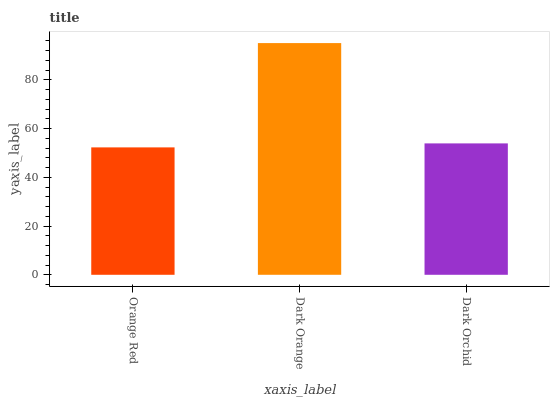Is Orange Red the minimum?
Answer yes or no. Yes. Is Dark Orange the maximum?
Answer yes or no. Yes. Is Dark Orchid the minimum?
Answer yes or no. No. Is Dark Orchid the maximum?
Answer yes or no. No. Is Dark Orange greater than Dark Orchid?
Answer yes or no. Yes. Is Dark Orchid less than Dark Orange?
Answer yes or no. Yes. Is Dark Orchid greater than Dark Orange?
Answer yes or no. No. Is Dark Orange less than Dark Orchid?
Answer yes or no. No. Is Dark Orchid the high median?
Answer yes or no. Yes. Is Dark Orchid the low median?
Answer yes or no. Yes. Is Orange Red the high median?
Answer yes or no. No. Is Dark Orange the low median?
Answer yes or no. No. 